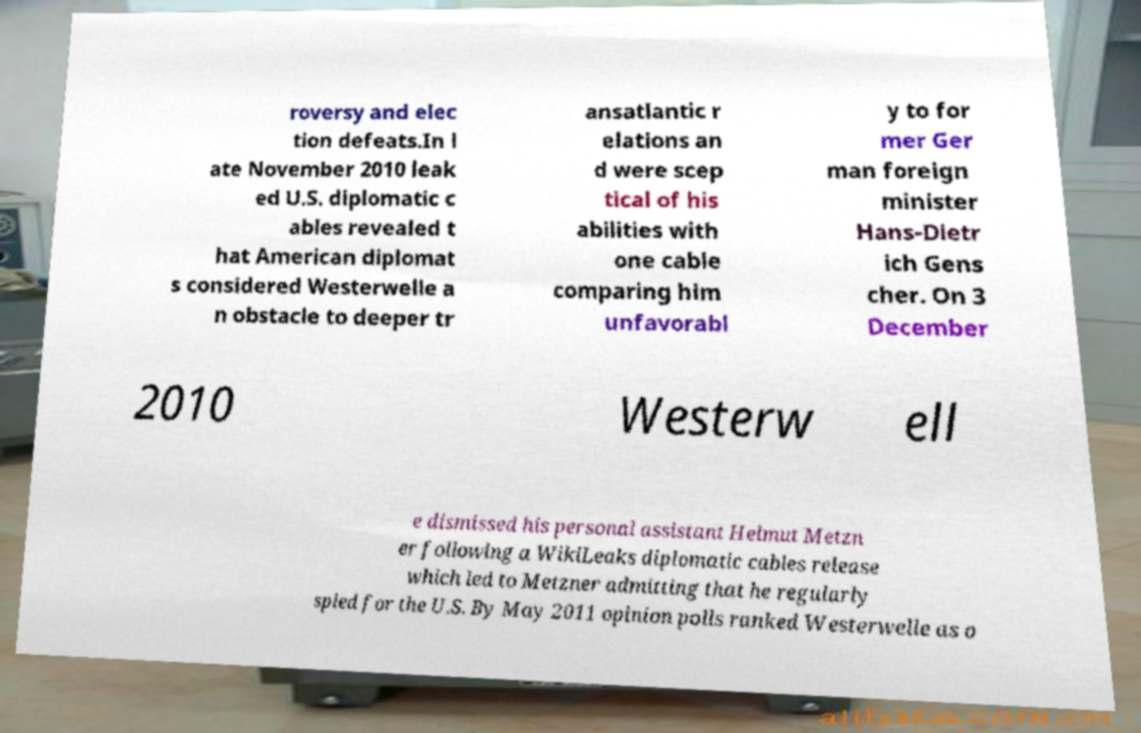Please read and relay the text visible in this image. What does it say? roversy and elec tion defeats.In l ate November 2010 leak ed U.S. diplomatic c ables revealed t hat American diplomat s considered Westerwelle a n obstacle to deeper tr ansatlantic r elations an d were scep tical of his abilities with one cable comparing him unfavorabl y to for mer Ger man foreign minister Hans-Dietr ich Gens cher. On 3 December 2010 Westerw ell e dismissed his personal assistant Helmut Metzn er following a WikiLeaks diplomatic cables release which led to Metzner admitting that he regularly spied for the U.S. By May 2011 opinion polls ranked Westerwelle as o 